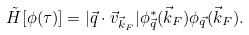<formula> <loc_0><loc_0><loc_500><loc_500>\tilde { H } [ \phi ( \tau ) ] = | \vec { q } \cdot \vec { v } _ { \vec { k } _ { F } } | \phi ^ { * } _ { \vec { q } } ( \vec { k } _ { F } ) \phi _ { \vec { q } } ( \vec { k } _ { F } ) .</formula> 